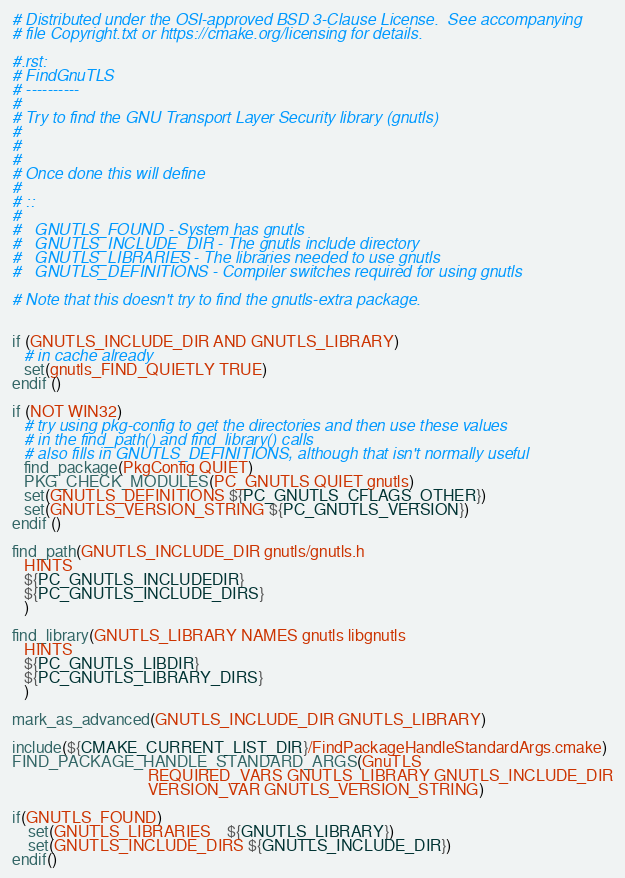<code> <loc_0><loc_0><loc_500><loc_500><_CMake_># Distributed under the OSI-approved BSD 3-Clause License.  See accompanying
# file Copyright.txt or https://cmake.org/licensing for details.

#.rst:
# FindGnuTLS
# ----------
#
# Try to find the GNU Transport Layer Security library (gnutls)
#
#
#
# Once done this will define
#
# ::
#
#   GNUTLS_FOUND - System has gnutls
#   GNUTLS_INCLUDE_DIR - The gnutls include directory
#   GNUTLS_LIBRARIES - The libraries needed to use gnutls
#   GNUTLS_DEFINITIONS - Compiler switches required for using gnutls

# Note that this doesn't try to find the gnutls-extra package.


if (GNUTLS_INCLUDE_DIR AND GNUTLS_LIBRARY)
   # in cache already
   set(gnutls_FIND_QUIETLY TRUE)
endif ()

if (NOT WIN32)
   # try using pkg-config to get the directories and then use these values
   # in the find_path() and find_library() calls
   # also fills in GNUTLS_DEFINITIONS, although that isn't normally useful
   find_package(PkgConfig QUIET)
   PKG_CHECK_MODULES(PC_GNUTLS QUIET gnutls)
   set(GNUTLS_DEFINITIONS ${PC_GNUTLS_CFLAGS_OTHER})
   set(GNUTLS_VERSION_STRING ${PC_GNUTLS_VERSION})
endif ()

find_path(GNUTLS_INCLUDE_DIR gnutls/gnutls.h
   HINTS
   ${PC_GNUTLS_INCLUDEDIR}
   ${PC_GNUTLS_INCLUDE_DIRS}
   )

find_library(GNUTLS_LIBRARY NAMES gnutls libgnutls
   HINTS
   ${PC_GNUTLS_LIBDIR}
   ${PC_GNUTLS_LIBRARY_DIRS}
   )

mark_as_advanced(GNUTLS_INCLUDE_DIR GNUTLS_LIBRARY)

include(${CMAKE_CURRENT_LIST_DIR}/FindPackageHandleStandardArgs.cmake)
FIND_PACKAGE_HANDLE_STANDARD_ARGS(GnuTLS
                                  REQUIRED_VARS GNUTLS_LIBRARY GNUTLS_INCLUDE_DIR
                                  VERSION_VAR GNUTLS_VERSION_STRING)

if(GNUTLS_FOUND)
    set(GNUTLS_LIBRARIES    ${GNUTLS_LIBRARY})
    set(GNUTLS_INCLUDE_DIRS ${GNUTLS_INCLUDE_DIR})
endif()
</code> 